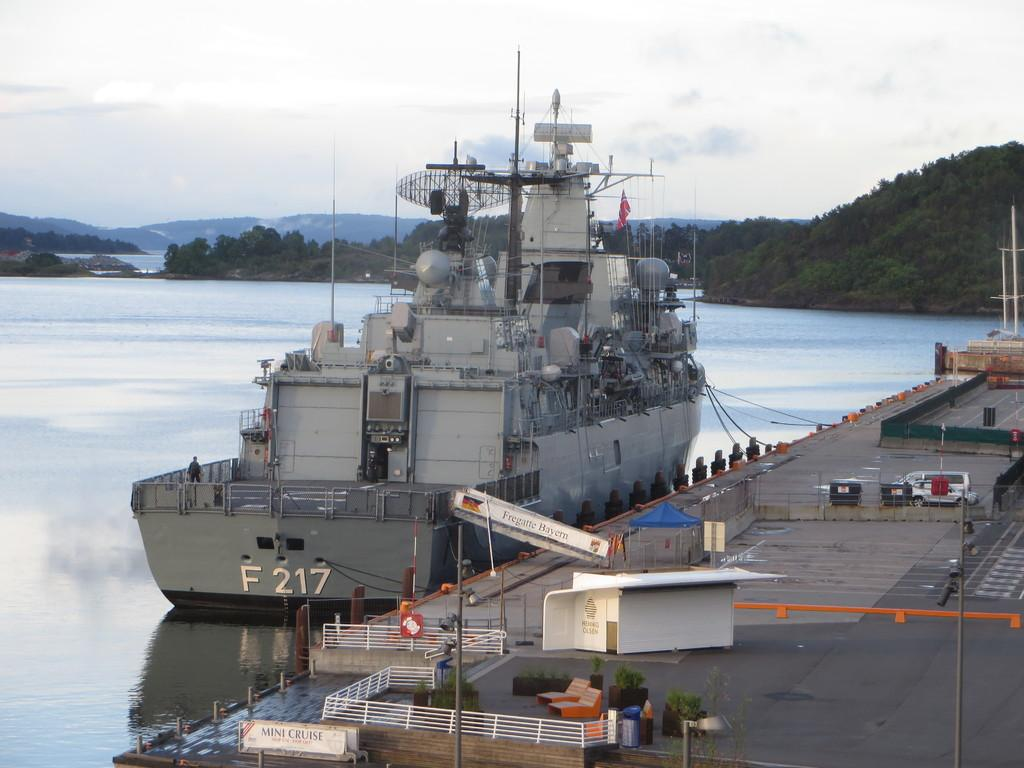What type of vehicle is at the deck in the image? There is a ship at the deck in the image. What structures can be seen in the image? There are poles, grills, chaise lounges, and a parasol in the image. What objects are present on the floor in the image? There are motor vehicles on the floor in the image. What signs can be seen in the image? There are name boards in the image. What type of containers are in the image? There are bins in the image. What type of natural features are visible in the image? There are trees, hills, and the sky in the image. What can be seen in the sky in the image? There are clouds in the sky in the image. What type of cream is being spread on the loaf in the image? There is no cream or loaf present in the image. How many attempts were made to climb the hill in the image? There is no indication of anyone attempting to climb the hill in the image. 